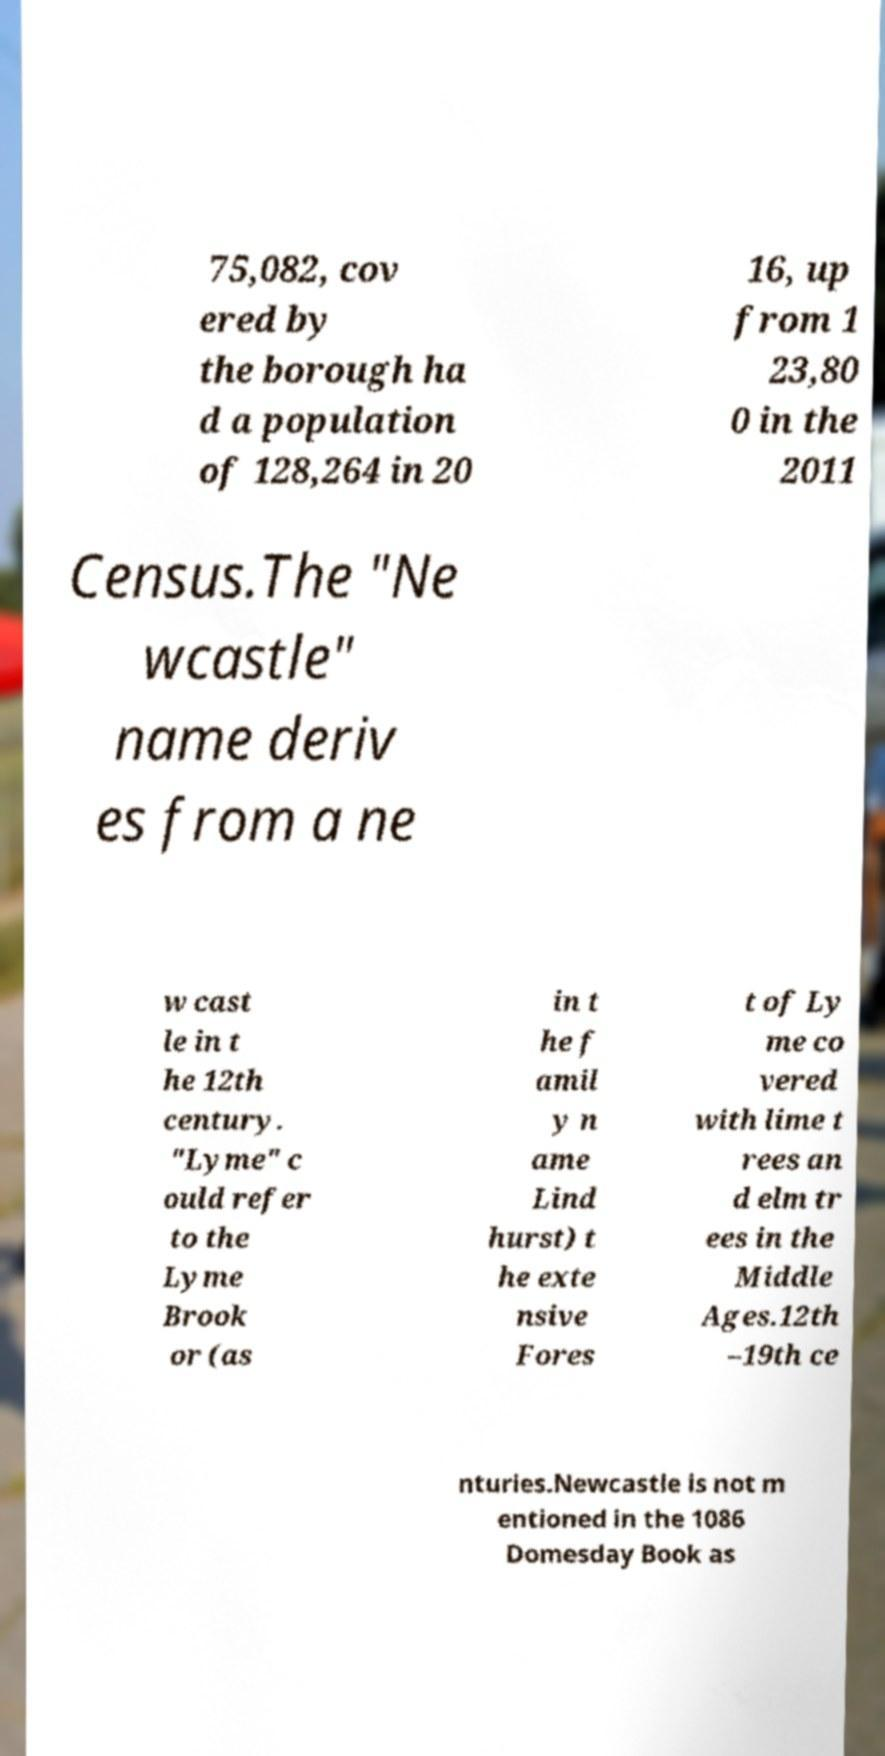Could you assist in decoding the text presented in this image and type it out clearly? 75,082, cov ered by the borough ha d a population of 128,264 in 20 16, up from 1 23,80 0 in the 2011 Census.The "Ne wcastle" name deriv es from a ne w cast le in t he 12th century. "Lyme" c ould refer to the Lyme Brook or (as in t he f amil y n ame Lind hurst) t he exte nsive Fores t of Ly me co vered with lime t rees an d elm tr ees in the Middle Ages.12th –19th ce nturies.Newcastle is not m entioned in the 1086 Domesday Book as 